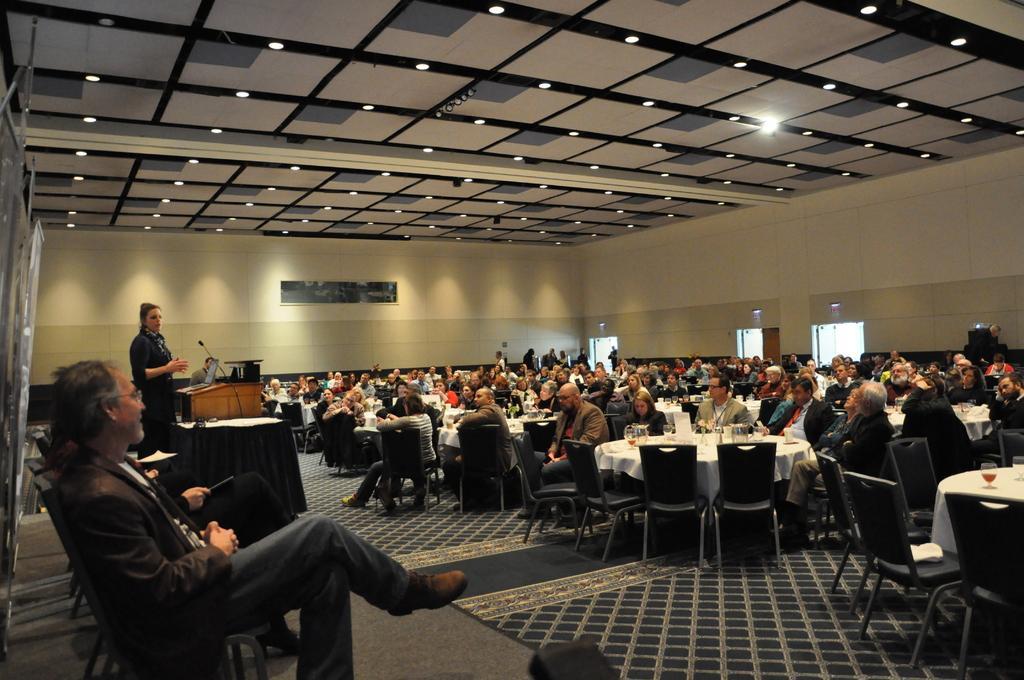Describe this image in one or two sentences. In this image there is a woman standing, there is a podium, there are objects on the podium, there are chairs, there are tables, there are clothes on the tables, there are objects on the clothes, there are a group of persons sitting, they are holding an object, there is floor towards the bottom of the image, there is a wall, there are objects on the wall, there is an object towards the left of the image, there is roof towards the top of the image, there are lights, there is an object towards the bottom of the image. 